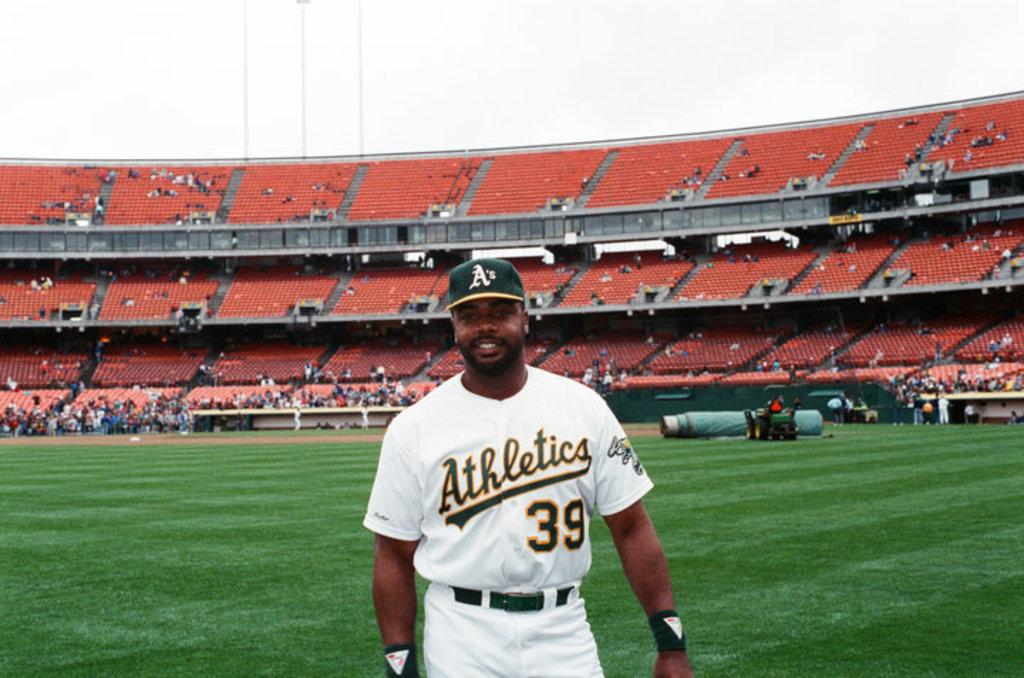Provide a one-sentence caption for the provided image. a oakland a player wearing a white athletic jersey number 39. 